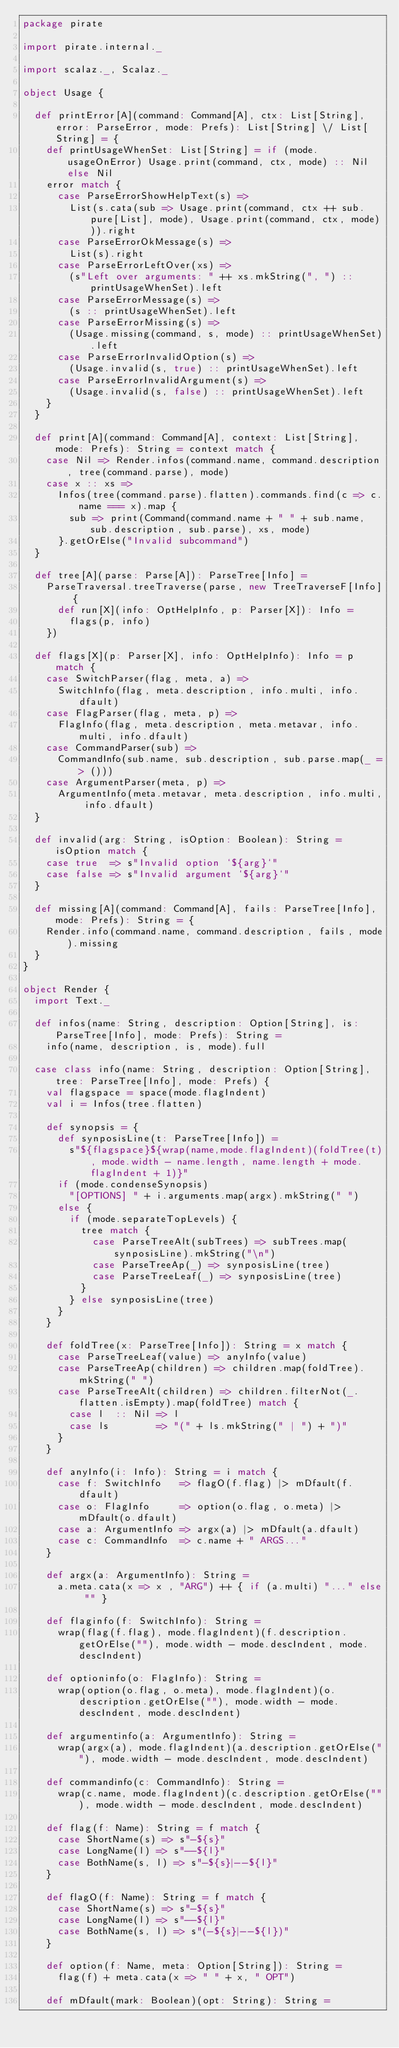Convert code to text. <code><loc_0><loc_0><loc_500><loc_500><_Scala_>package pirate

import pirate.internal._

import scalaz._, Scalaz._

object Usage {

  def printError[A](command: Command[A], ctx: List[String], error: ParseError, mode: Prefs): List[String] \/ List[String] = {
    def printUsageWhenSet: List[String] = if (mode.usageOnError) Usage.print(command, ctx, mode) :: Nil else Nil
    error match {
      case ParseErrorShowHelpText(s) =>
        List(s.cata(sub => Usage.print(command, ctx ++ sub.pure[List], mode), Usage.print(command, ctx, mode))).right
      case ParseErrorOkMessage(s) =>
        List(s).right
      case ParseErrorLeftOver(xs) =>
        (s"Left over arguments: " ++ xs.mkString(", ") :: printUsageWhenSet).left
      case ParseErrorMessage(s) =>
        (s :: printUsageWhenSet).left
      case ParseErrorMissing(s) =>
        (Usage.missing(command, s, mode) :: printUsageWhenSet).left
      case ParseErrorInvalidOption(s) =>
        (Usage.invalid(s, true) :: printUsageWhenSet).left
      case ParseErrorInvalidArgument(s) =>
        (Usage.invalid(s, false) :: printUsageWhenSet).left
    }
  }

  def print[A](command: Command[A], context: List[String], mode: Prefs): String = context match {
    case Nil => Render.infos(command.name, command.description, tree(command.parse), mode)
    case x :: xs =>
      Infos(tree(command.parse).flatten).commands.find(c => c.name === x).map {
        sub => print(Command(command.name + " " + sub.name, sub.description, sub.parse), xs, mode)
      }.getOrElse("Invalid subcommand")
  }

  def tree[A](parse: Parse[A]): ParseTree[Info] =
    ParseTraversal.treeTraverse(parse, new TreeTraverseF[Info] {
      def run[X](info: OptHelpInfo, p: Parser[X]): Info =
        flags(p, info)
    })

  def flags[X](p: Parser[X], info: OptHelpInfo): Info = p match {
    case SwitchParser(flag, meta, a) =>
      SwitchInfo(flag, meta.description, info.multi, info.dfault)
    case FlagParser(flag, meta, p) =>
      FlagInfo(flag, meta.description, meta.metavar, info.multi, info.dfault)
    case CommandParser(sub) =>
      CommandInfo(sub.name, sub.description, sub.parse.map(_ => ()))
    case ArgumentParser(meta, p) =>
      ArgumentInfo(meta.metavar, meta.description, info.multi, info.dfault)
  }

  def invalid(arg: String, isOption: Boolean): String = isOption match {
    case true  => s"Invalid option `${arg}`"
    case false => s"Invalid argument `${arg}`"
  }

  def missing[A](command: Command[A], fails: ParseTree[Info], mode: Prefs): String = {
    Render.info(command.name, command.description, fails, mode).missing
  }
}

object Render {
  import Text._

  def infos(name: String, description: Option[String], is: ParseTree[Info], mode: Prefs): String =
    info(name, description, is, mode).full

  case class info(name: String, description: Option[String], tree: ParseTree[Info], mode: Prefs) {
    val flagspace = space(mode.flagIndent)
    val i = Infos(tree.flatten)

    def synopsis = {
      def synposisLine(t: ParseTree[Info]) =
        s"${flagspace}${wrap(name,mode.flagIndent)(foldTree(t), mode.width - name.length, name.length + mode.flagIndent + 1)}"
      if (mode.condenseSynopsis)
        "[OPTIONS] " + i.arguments.map(argx).mkString(" ")
      else {
        if (mode.separateTopLevels) {
          tree match {
            case ParseTreeAlt(subTrees) => subTrees.map(synposisLine).mkString("\n")
            case ParseTreeAp(_) => synposisLine(tree)
            case ParseTreeLeaf(_) => synposisLine(tree)
          }
        } else synposisLine(tree)
      }
    }

    def foldTree(x: ParseTree[Info]): String = x match {
      case ParseTreeLeaf(value) => anyInfo(value)
      case ParseTreeAp(children) => children.map(foldTree).mkString(" ")
      case ParseTreeAlt(children) => children.filterNot(_.flatten.isEmpty).map(foldTree) match {
        case l  :: Nil => l
        case ls        => "(" + ls.mkString(" | ") + ")"
      }
    }

    def anyInfo(i: Info): String = i match {
      case f: SwitchInfo   => flagO(f.flag) |> mDfault(f.dfault)
      case o: FlagInfo     => option(o.flag, o.meta) |> mDfault(o.dfault)
      case a: ArgumentInfo => argx(a) |> mDfault(a.dfault)
      case c: CommandInfo  => c.name + " ARGS..."
    }

    def argx(a: ArgumentInfo): String =
      a.meta.cata(x => x , "ARG") ++ { if (a.multi) "..." else "" }

    def flaginfo(f: SwitchInfo): String =
      wrap(flag(f.flag), mode.flagIndent)(f.description.getOrElse(""), mode.width - mode.descIndent, mode.descIndent)

    def optioninfo(o: FlagInfo): String =
      wrap(option(o.flag, o.meta), mode.flagIndent)(o.description.getOrElse(""), mode.width - mode.descIndent, mode.descIndent)

    def argumentinfo(a: ArgumentInfo): String =
      wrap(argx(a), mode.flagIndent)(a.description.getOrElse(""), mode.width - mode.descIndent, mode.descIndent)

    def commandinfo(c: CommandInfo): String =
      wrap(c.name, mode.flagIndent)(c.description.getOrElse(""), mode.width - mode.descIndent, mode.descIndent)

    def flag(f: Name): String = f match {
      case ShortName(s) => s"-${s}"
      case LongName(l) => s"--${l}"
      case BothName(s, l) => s"-${s}|--${l}"
    }

    def flagO(f: Name): String = f match {
      case ShortName(s) => s"-${s}"
      case LongName(l) => s"--${l}"
      case BothName(s, l) => s"(-${s}|--${l})"
    }

    def option(f: Name, meta: Option[String]): String =
      flag(f) + meta.cata(x => " " + x, " OPT")

    def mDfault(mark: Boolean)(opt: String): String =</code> 